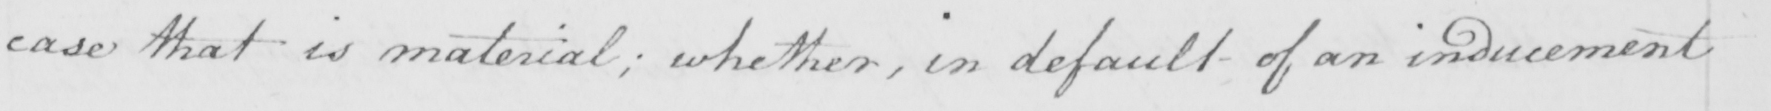Please transcribe the handwritten text in this image. case that is material ; whether , in default of an inducement 